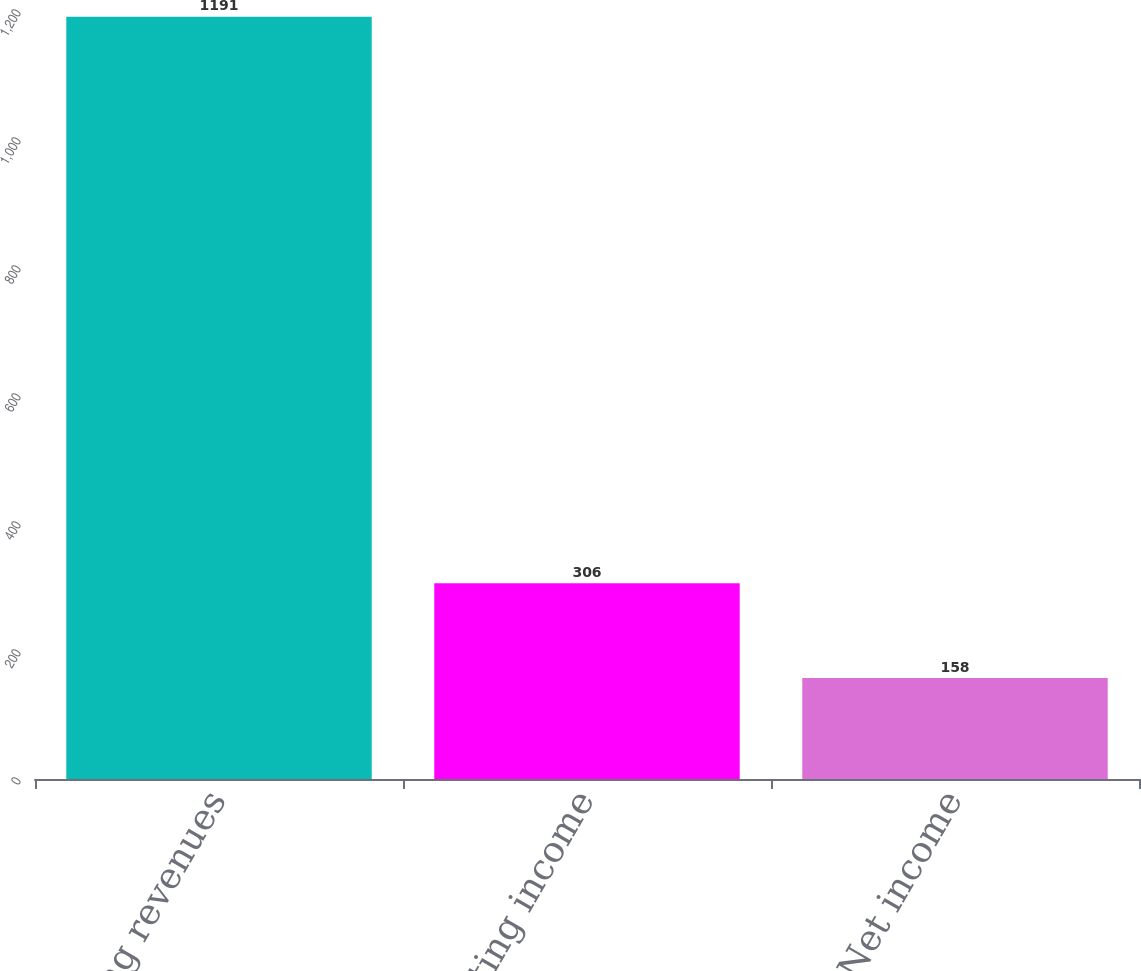<chart> <loc_0><loc_0><loc_500><loc_500><bar_chart><fcel>Operating revenues<fcel>Operating income<fcel>Net income<nl><fcel>1191<fcel>306<fcel>158<nl></chart> 